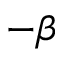<formula> <loc_0><loc_0><loc_500><loc_500>- \beta</formula> 